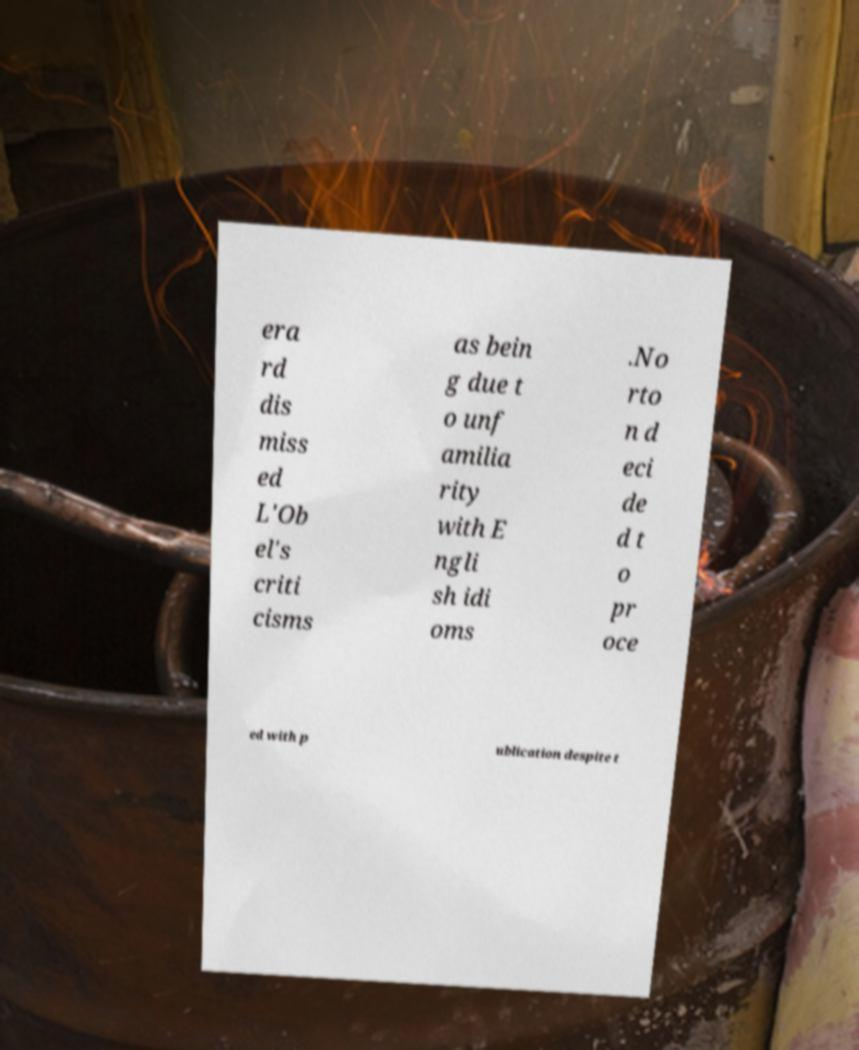Could you assist in decoding the text presented in this image and type it out clearly? era rd dis miss ed L'Ob el's criti cisms as bein g due t o unf amilia rity with E ngli sh idi oms .No rto n d eci de d t o pr oce ed with p ublication despite t 